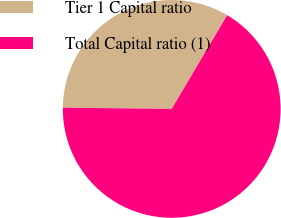<chart> <loc_0><loc_0><loc_500><loc_500><pie_chart><fcel>Tier 1 Capital ratio<fcel>Total Capital ratio (1)<nl><fcel>33.33%<fcel>66.67%<nl></chart> 